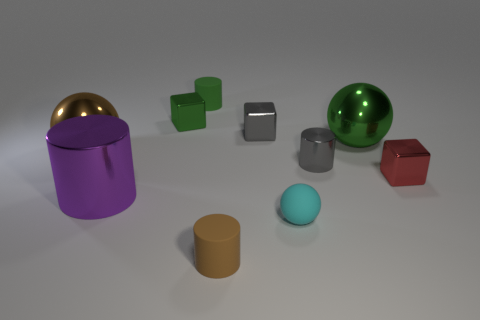Can you describe the texture of the red cube in this image? The red cube in the image has a slightly matte texture, which diffuses the light, resulting in a soft appearance without strong reflections. 